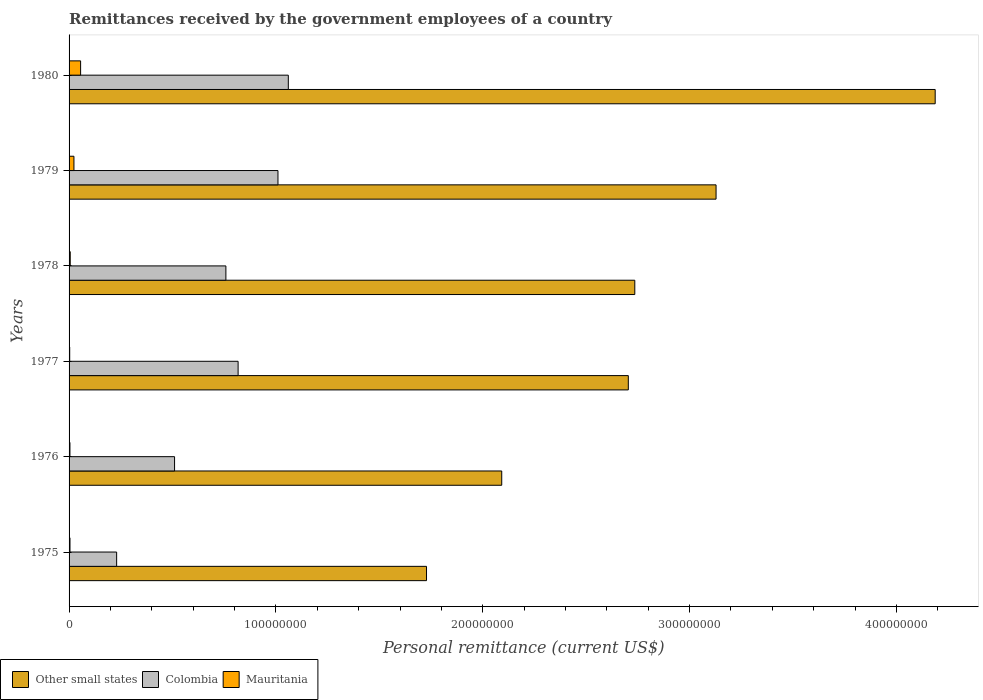Are the number of bars per tick equal to the number of legend labels?
Offer a terse response. Yes. How many bars are there on the 4th tick from the top?
Provide a short and direct response. 3. How many bars are there on the 5th tick from the bottom?
Keep it short and to the point. 3. What is the label of the 6th group of bars from the top?
Your answer should be compact. 1975. What is the remittances received by the government employees in Other small states in 1977?
Make the answer very short. 2.70e+08. Across all years, what is the maximum remittances received by the government employees in Mauritania?
Provide a succinct answer. 5.58e+06. Across all years, what is the minimum remittances received by the government employees in Other small states?
Keep it short and to the point. 1.73e+08. In which year was the remittances received by the government employees in Colombia maximum?
Offer a terse response. 1980. In which year was the remittances received by the government employees in Colombia minimum?
Keep it short and to the point. 1975. What is the total remittances received by the government employees in Other small states in the graph?
Your response must be concise. 1.66e+09. What is the difference between the remittances received by the government employees in Mauritania in 1976 and that in 1979?
Offer a very short reply. -1.93e+06. What is the difference between the remittances received by the government employees in Other small states in 1980 and the remittances received by the government employees in Mauritania in 1975?
Offer a terse response. 4.18e+08. What is the average remittances received by the government employees in Mauritania per year?
Your answer should be compact. 1.61e+06. In the year 1976, what is the difference between the remittances received by the government employees in Colombia and remittances received by the government employees in Other small states?
Provide a succinct answer. -1.58e+08. What is the ratio of the remittances received by the government employees in Other small states in 1977 to that in 1979?
Your answer should be compact. 0.86. Is the remittances received by the government employees in Colombia in 1975 less than that in 1980?
Provide a short and direct response. Yes. What is the difference between the highest and the second highest remittances received by the government employees in Other small states?
Your answer should be very brief. 1.06e+08. What is the difference between the highest and the lowest remittances received by the government employees in Mauritania?
Provide a short and direct response. 5.27e+06. In how many years, is the remittances received by the government employees in Other small states greater than the average remittances received by the government employees in Other small states taken over all years?
Give a very brief answer. 2. Is the sum of the remittances received by the government employees in Other small states in 1976 and 1980 greater than the maximum remittances received by the government employees in Colombia across all years?
Offer a very short reply. Yes. What does the 2nd bar from the bottom in 1976 represents?
Your answer should be compact. Colombia. How many bars are there?
Provide a succinct answer. 18. Are all the bars in the graph horizontal?
Offer a terse response. Yes. How many years are there in the graph?
Your answer should be very brief. 6. Does the graph contain any zero values?
Ensure brevity in your answer.  No. Does the graph contain grids?
Provide a short and direct response. No. How are the legend labels stacked?
Offer a terse response. Horizontal. What is the title of the graph?
Provide a succinct answer. Remittances received by the government employees of a country. Does "Macedonia" appear as one of the legend labels in the graph?
Your answer should be compact. No. What is the label or title of the X-axis?
Keep it short and to the point. Personal remittance (current US$). What is the Personal remittance (current US$) in Other small states in 1975?
Offer a very short reply. 1.73e+08. What is the Personal remittance (current US$) of Colombia in 1975?
Offer a terse response. 2.30e+07. What is the Personal remittance (current US$) of Mauritania in 1975?
Offer a terse response. 4.41e+05. What is the Personal remittance (current US$) in Other small states in 1976?
Ensure brevity in your answer.  2.09e+08. What is the Personal remittance (current US$) in Colombia in 1976?
Provide a short and direct response. 5.10e+07. What is the Personal remittance (current US$) of Mauritania in 1976?
Offer a very short reply. 4.22e+05. What is the Personal remittance (current US$) of Other small states in 1977?
Make the answer very short. 2.70e+08. What is the Personal remittance (current US$) of Colombia in 1977?
Offer a terse response. 8.17e+07. What is the Personal remittance (current US$) of Mauritania in 1977?
Offer a very short reply. 3.07e+05. What is the Personal remittance (current US$) of Other small states in 1978?
Your answer should be very brief. 2.74e+08. What is the Personal remittance (current US$) in Colombia in 1978?
Offer a terse response. 7.58e+07. What is the Personal remittance (current US$) of Mauritania in 1978?
Your response must be concise. 5.63e+05. What is the Personal remittance (current US$) in Other small states in 1979?
Your response must be concise. 3.13e+08. What is the Personal remittance (current US$) of Colombia in 1979?
Make the answer very short. 1.01e+08. What is the Personal remittance (current US$) in Mauritania in 1979?
Ensure brevity in your answer.  2.35e+06. What is the Personal remittance (current US$) of Other small states in 1980?
Your answer should be compact. 4.19e+08. What is the Personal remittance (current US$) in Colombia in 1980?
Keep it short and to the point. 1.06e+08. What is the Personal remittance (current US$) of Mauritania in 1980?
Your answer should be very brief. 5.58e+06. Across all years, what is the maximum Personal remittance (current US$) in Other small states?
Your response must be concise. 4.19e+08. Across all years, what is the maximum Personal remittance (current US$) in Colombia?
Give a very brief answer. 1.06e+08. Across all years, what is the maximum Personal remittance (current US$) in Mauritania?
Offer a terse response. 5.58e+06. Across all years, what is the minimum Personal remittance (current US$) in Other small states?
Your response must be concise. 1.73e+08. Across all years, what is the minimum Personal remittance (current US$) in Colombia?
Provide a succinct answer. 2.30e+07. Across all years, what is the minimum Personal remittance (current US$) in Mauritania?
Your answer should be compact. 3.07e+05. What is the total Personal remittance (current US$) of Other small states in the graph?
Your answer should be very brief. 1.66e+09. What is the total Personal remittance (current US$) in Colombia in the graph?
Give a very brief answer. 4.39e+08. What is the total Personal remittance (current US$) in Mauritania in the graph?
Your response must be concise. 9.66e+06. What is the difference between the Personal remittance (current US$) in Other small states in 1975 and that in 1976?
Ensure brevity in your answer.  -3.64e+07. What is the difference between the Personal remittance (current US$) in Colombia in 1975 and that in 1976?
Your answer should be compact. -2.80e+07. What is the difference between the Personal remittance (current US$) in Mauritania in 1975 and that in 1976?
Keep it short and to the point. 1.88e+04. What is the difference between the Personal remittance (current US$) of Other small states in 1975 and that in 1977?
Offer a very short reply. -9.76e+07. What is the difference between the Personal remittance (current US$) in Colombia in 1975 and that in 1977?
Your response must be concise. -5.87e+07. What is the difference between the Personal remittance (current US$) of Mauritania in 1975 and that in 1977?
Keep it short and to the point. 1.34e+05. What is the difference between the Personal remittance (current US$) of Other small states in 1975 and that in 1978?
Give a very brief answer. -1.01e+08. What is the difference between the Personal remittance (current US$) in Colombia in 1975 and that in 1978?
Ensure brevity in your answer.  -5.28e+07. What is the difference between the Personal remittance (current US$) in Mauritania in 1975 and that in 1978?
Your answer should be very brief. -1.22e+05. What is the difference between the Personal remittance (current US$) of Other small states in 1975 and that in 1979?
Give a very brief answer. -1.40e+08. What is the difference between the Personal remittance (current US$) of Colombia in 1975 and that in 1979?
Keep it short and to the point. -7.80e+07. What is the difference between the Personal remittance (current US$) of Mauritania in 1975 and that in 1979?
Provide a succinct answer. -1.91e+06. What is the difference between the Personal remittance (current US$) in Other small states in 1975 and that in 1980?
Your answer should be very brief. -2.46e+08. What is the difference between the Personal remittance (current US$) in Colombia in 1975 and that in 1980?
Your response must be concise. -8.30e+07. What is the difference between the Personal remittance (current US$) of Mauritania in 1975 and that in 1980?
Keep it short and to the point. -5.13e+06. What is the difference between the Personal remittance (current US$) in Other small states in 1976 and that in 1977?
Offer a terse response. -6.12e+07. What is the difference between the Personal remittance (current US$) of Colombia in 1976 and that in 1977?
Offer a terse response. -3.07e+07. What is the difference between the Personal remittance (current US$) in Mauritania in 1976 and that in 1977?
Give a very brief answer. 1.15e+05. What is the difference between the Personal remittance (current US$) in Other small states in 1976 and that in 1978?
Ensure brevity in your answer.  -6.43e+07. What is the difference between the Personal remittance (current US$) of Colombia in 1976 and that in 1978?
Your answer should be compact. -2.48e+07. What is the difference between the Personal remittance (current US$) of Mauritania in 1976 and that in 1978?
Give a very brief answer. -1.41e+05. What is the difference between the Personal remittance (current US$) in Other small states in 1976 and that in 1979?
Ensure brevity in your answer.  -1.04e+08. What is the difference between the Personal remittance (current US$) in Colombia in 1976 and that in 1979?
Provide a short and direct response. -5.00e+07. What is the difference between the Personal remittance (current US$) in Mauritania in 1976 and that in 1979?
Your answer should be very brief. -1.93e+06. What is the difference between the Personal remittance (current US$) in Other small states in 1976 and that in 1980?
Your answer should be compact. -2.10e+08. What is the difference between the Personal remittance (current US$) in Colombia in 1976 and that in 1980?
Ensure brevity in your answer.  -5.50e+07. What is the difference between the Personal remittance (current US$) in Mauritania in 1976 and that in 1980?
Provide a succinct answer. -5.15e+06. What is the difference between the Personal remittance (current US$) of Other small states in 1977 and that in 1978?
Offer a very short reply. -3.13e+06. What is the difference between the Personal remittance (current US$) in Colombia in 1977 and that in 1978?
Ensure brevity in your answer.  5.91e+06. What is the difference between the Personal remittance (current US$) in Mauritania in 1977 and that in 1978?
Your answer should be compact. -2.56e+05. What is the difference between the Personal remittance (current US$) of Other small states in 1977 and that in 1979?
Your response must be concise. -4.24e+07. What is the difference between the Personal remittance (current US$) of Colombia in 1977 and that in 1979?
Ensure brevity in your answer.  -1.93e+07. What is the difference between the Personal remittance (current US$) in Mauritania in 1977 and that in 1979?
Ensure brevity in your answer.  -2.05e+06. What is the difference between the Personal remittance (current US$) of Other small states in 1977 and that in 1980?
Your answer should be compact. -1.48e+08. What is the difference between the Personal remittance (current US$) of Colombia in 1977 and that in 1980?
Keep it short and to the point. -2.43e+07. What is the difference between the Personal remittance (current US$) in Mauritania in 1977 and that in 1980?
Offer a terse response. -5.27e+06. What is the difference between the Personal remittance (current US$) of Other small states in 1978 and that in 1979?
Provide a succinct answer. -3.93e+07. What is the difference between the Personal remittance (current US$) of Colombia in 1978 and that in 1979?
Ensure brevity in your answer.  -2.52e+07. What is the difference between the Personal remittance (current US$) in Mauritania in 1978 and that in 1979?
Make the answer very short. -1.79e+06. What is the difference between the Personal remittance (current US$) in Other small states in 1978 and that in 1980?
Offer a terse response. -1.45e+08. What is the difference between the Personal remittance (current US$) in Colombia in 1978 and that in 1980?
Your answer should be very brief. -3.02e+07. What is the difference between the Personal remittance (current US$) of Mauritania in 1978 and that in 1980?
Provide a short and direct response. -5.01e+06. What is the difference between the Personal remittance (current US$) in Other small states in 1979 and that in 1980?
Offer a terse response. -1.06e+08. What is the difference between the Personal remittance (current US$) in Colombia in 1979 and that in 1980?
Offer a very short reply. -5.00e+06. What is the difference between the Personal remittance (current US$) in Mauritania in 1979 and that in 1980?
Provide a succinct answer. -3.22e+06. What is the difference between the Personal remittance (current US$) in Other small states in 1975 and the Personal remittance (current US$) in Colombia in 1976?
Provide a succinct answer. 1.22e+08. What is the difference between the Personal remittance (current US$) of Other small states in 1975 and the Personal remittance (current US$) of Mauritania in 1976?
Make the answer very short. 1.72e+08. What is the difference between the Personal remittance (current US$) of Colombia in 1975 and the Personal remittance (current US$) of Mauritania in 1976?
Provide a succinct answer. 2.26e+07. What is the difference between the Personal remittance (current US$) in Other small states in 1975 and the Personal remittance (current US$) in Colombia in 1977?
Provide a short and direct response. 9.11e+07. What is the difference between the Personal remittance (current US$) of Other small states in 1975 and the Personal remittance (current US$) of Mauritania in 1977?
Ensure brevity in your answer.  1.73e+08. What is the difference between the Personal remittance (current US$) in Colombia in 1975 and the Personal remittance (current US$) in Mauritania in 1977?
Ensure brevity in your answer.  2.27e+07. What is the difference between the Personal remittance (current US$) in Other small states in 1975 and the Personal remittance (current US$) in Colombia in 1978?
Your answer should be very brief. 9.70e+07. What is the difference between the Personal remittance (current US$) in Other small states in 1975 and the Personal remittance (current US$) in Mauritania in 1978?
Your response must be concise. 1.72e+08. What is the difference between the Personal remittance (current US$) of Colombia in 1975 and the Personal remittance (current US$) of Mauritania in 1978?
Keep it short and to the point. 2.24e+07. What is the difference between the Personal remittance (current US$) in Other small states in 1975 and the Personal remittance (current US$) in Colombia in 1979?
Make the answer very short. 7.18e+07. What is the difference between the Personal remittance (current US$) in Other small states in 1975 and the Personal remittance (current US$) in Mauritania in 1979?
Give a very brief answer. 1.70e+08. What is the difference between the Personal remittance (current US$) in Colombia in 1975 and the Personal remittance (current US$) in Mauritania in 1979?
Your answer should be very brief. 2.06e+07. What is the difference between the Personal remittance (current US$) in Other small states in 1975 and the Personal remittance (current US$) in Colombia in 1980?
Make the answer very short. 6.68e+07. What is the difference between the Personal remittance (current US$) of Other small states in 1975 and the Personal remittance (current US$) of Mauritania in 1980?
Your answer should be compact. 1.67e+08. What is the difference between the Personal remittance (current US$) in Colombia in 1975 and the Personal remittance (current US$) in Mauritania in 1980?
Keep it short and to the point. 1.74e+07. What is the difference between the Personal remittance (current US$) in Other small states in 1976 and the Personal remittance (current US$) in Colombia in 1977?
Ensure brevity in your answer.  1.27e+08. What is the difference between the Personal remittance (current US$) in Other small states in 1976 and the Personal remittance (current US$) in Mauritania in 1977?
Offer a terse response. 2.09e+08. What is the difference between the Personal remittance (current US$) of Colombia in 1976 and the Personal remittance (current US$) of Mauritania in 1977?
Your answer should be very brief. 5.07e+07. What is the difference between the Personal remittance (current US$) in Other small states in 1976 and the Personal remittance (current US$) in Colombia in 1978?
Your answer should be compact. 1.33e+08. What is the difference between the Personal remittance (current US$) in Other small states in 1976 and the Personal remittance (current US$) in Mauritania in 1978?
Make the answer very short. 2.09e+08. What is the difference between the Personal remittance (current US$) in Colombia in 1976 and the Personal remittance (current US$) in Mauritania in 1978?
Your answer should be compact. 5.04e+07. What is the difference between the Personal remittance (current US$) in Other small states in 1976 and the Personal remittance (current US$) in Colombia in 1979?
Keep it short and to the point. 1.08e+08. What is the difference between the Personal remittance (current US$) in Other small states in 1976 and the Personal remittance (current US$) in Mauritania in 1979?
Your answer should be very brief. 2.07e+08. What is the difference between the Personal remittance (current US$) in Colombia in 1976 and the Personal remittance (current US$) in Mauritania in 1979?
Make the answer very short. 4.86e+07. What is the difference between the Personal remittance (current US$) of Other small states in 1976 and the Personal remittance (current US$) of Colombia in 1980?
Offer a very short reply. 1.03e+08. What is the difference between the Personal remittance (current US$) in Other small states in 1976 and the Personal remittance (current US$) in Mauritania in 1980?
Ensure brevity in your answer.  2.04e+08. What is the difference between the Personal remittance (current US$) in Colombia in 1976 and the Personal remittance (current US$) in Mauritania in 1980?
Your response must be concise. 4.54e+07. What is the difference between the Personal remittance (current US$) of Other small states in 1977 and the Personal remittance (current US$) of Colombia in 1978?
Your answer should be very brief. 1.95e+08. What is the difference between the Personal remittance (current US$) of Other small states in 1977 and the Personal remittance (current US$) of Mauritania in 1978?
Your answer should be very brief. 2.70e+08. What is the difference between the Personal remittance (current US$) in Colombia in 1977 and the Personal remittance (current US$) in Mauritania in 1978?
Your answer should be very brief. 8.12e+07. What is the difference between the Personal remittance (current US$) in Other small states in 1977 and the Personal remittance (current US$) in Colombia in 1979?
Your response must be concise. 1.69e+08. What is the difference between the Personal remittance (current US$) in Other small states in 1977 and the Personal remittance (current US$) in Mauritania in 1979?
Your answer should be very brief. 2.68e+08. What is the difference between the Personal remittance (current US$) in Colombia in 1977 and the Personal remittance (current US$) in Mauritania in 1979?
Give a very brief answer. 7.94e+07. What is the difference between the Personal remittance (current US$) of Other small states in 1977 and the Personal remittance (current US$) of Colombia in 1980?
Ensure brevity in your answer.  1.64e+08. What is the difference between the Personal remittance (current US$) of Other small states in 1977 and the Personal remittance (current US$) of Mauritania in 1980?
Provide a succinct answer. 2.65e+08. What is the difference between the Personal remittance (current US$) of Colombia in 1977 and the Personal remittance (current US$) of Mauritania in 1980?
Keep it short and to the point. 7.62e+07. What is the difference between the Personal remittance (current US$) in Other small states in 1978 and the Personal remittance (current US$) in Colombia in 1979?
Keep it short and to the point. 1.73e+08. What is the difference between the Personal remittance (current US$) of Other small states in 1978 and the Personal remittance (current US$) of Mauritania in 1979?
Provide a succinct answer. 2.71e+08. What is the difference between the Personal remittance (current US$) in Colombia in 1978 and the Personal remittance (current US$) in Mauritania in 1979?
Offer a terse response. 7.35e+07. What is the difference between the Personal remittance (current US$) in Other small states in 1978 and the Personal remittance (current US$) in Colombia in 1980?
Provide a short and direct response. 1.68e+08. What is the difference between the Personal remittance (current US$) in Other small states in 1978 and the Personal remittance (current US$) in Mauritania in 1980?
Make the answer very short. 2.68e+08. What is the difference between the Personal remittance (current US$) of Colombia in 1978 and the Personal remittance (current US$) of Mauritania in 1980?
Provide a short and direct response. 7.02e+07. What is the difference between the Personal remittance (current US$) of Other small states in 1979 and the Personal remittance (current US$) of Colombia in 1980?
Offer a terse response. 2.07e+08. What is the difference between the Personal remittance (current US$) in Other small states in 1979 and the Personal remittance (current US$) in Mauritania in 1980?
Ensure brevity in your answer.  3.07e+08. What is the difference between the Personal remittance (current US$) in Colombia in 1979 and the Personal remittance (current US$) in Mauritania in 1980?
Make the answer very short. 9.54e+07. What is the average Personal remittance (current US$) in Other small states per year?
Make the answer very short. 2.76e+08. What is the average Personal remittance (current US$) of Colombia per year?
Ensure brevity in your answer.  7.31e+07. What is the average Personal remittance (current US$) in Mauritania per year?
Your response must be concise. 1.61e+06. In the year 1975, what is the difference between the Personal remittance (current US$) in Other small states and Personal remittance (current US$) in Colombia?
Your answer should be very brief. 1.50e+08. In the year 1975, what is the difference between the Personal remittance (current US$) of Other small states and Personal remittance (current US$) of Mauritania?
Offer a terse response. 1.72e+08. In the year 1975, what is the difference between the Personal remittance (current US$) of Colombia and Personal remittance (current US$) of Mauritania?
Make the answer very short. 2.26e+07. In the year 1976, what is the difference between the Personal remittance (current US$) in Other small states and Personal remittance (current US$) in Colombia?
Offer a very short reply. 1.58e+08. In the year 1976, what is the difference between the Personal remittance (current US$) of Other small states and Personal remittance (current US$) of Mauritania?
Your answer should be compact. 2.09e+08. In the year 1976, what is the difference between the Personal remittance (current US$) of Colombia and Personal remittance (current US$) of Mauritania?
Keep it short and to the point. 5.06e+07. In the year 1977, what is the difference between the Personal remittance (current US$) in Other small states and Personal remittance (current US$) in Colombia?
Your response must be concise. 1.89e+08. In the year 1977, what is the difference between the Personal remittance (current US$) of Other small states and Personal remittance (current US$) of Mauritania?
Offer a terse response. 2.70e+08. In the year 1977, what is the difference between the Personal remittance (current US$) in Colombia and Personal remittance (current US$) in Mauritania?
Ensure brevity in your answer.  8.14e+07. In the year 1978, what is the difference between the Personal remittance (current US$) in Other small states and Personal remittance (current US$) in Colombia?
Offer a very short reply. 1.98e+08. In the year 1978, what is the difference between the Personal remittance (current US$) of Other small states and Personal remittance (current US$) of Mauritania?
Keep it short and to the point. 2.73e+08. In the year 1978, what is the difference between the Personal remittance (current US$) in Colombia and Personal remittance (current US$) in Mauritania?
Provide a short and direct response. 7.53e+07. In the year 1979, what is the difference between the Personal remittance (current US$) of Other small states and Personal remittance (current US$) of Colombia?
Provide a succinct answer. 2.12e+08. In the year 1979, what is the difference between the Personal remittance (current US$) of Other small states and Personal remittance (current US$) of Mauritania?
Provide a succinct answer. 3.10e+08. In the year 1979, what is the difference between the Personal remittance (current US$) of Colombia and Personal remittance (current US$) of Mauritania?
Give a very brief answer. 9.86e+07. In the year 1980, what is the difference between the Personal remittance (current US$) of Other small states and Personal remittance (current US$) of Colombia?
Your answer should be very brief. 3.13e+08. In the year 1980, what is the difference between the Personal remittance (current US$) in Other small states and Personal remittance (current US$) in Mauritania?
Offer a very short reply. 4.13e+08. In the year 1980, what is the difference between the Personal remittance (current US$) in Colombia and Personal remittance (current US$) in Mauritania?
Your answer should be very brief. 1.00e+08. What is the ratio of the Personal remittance (current US$) of Other small states in 1975 to that in 1976?
Ensure brevity in your answer.  0.83. What is the ratio of the Personal remittance (current US$) of Colombia in 1975 to that in 1976?
Provide a short and direct response. 0.45. What is the ratio of the Personal remittance (current US$) in Mauritania in 1975 to that in 1976?
Your answer should be compact. 1.04. What is the ratio of the Personal remittance (current US$) of Other small states in 1975 to that in 1977?
Offer a very short reply. 0.64. What is the ratio of the Personal remittance (current US$) of Colombia in 1975 to that in 1977?
Give a very brief answer. 0.28. What is the ratio of the Personal remittance (current US$) of Mauritania in 1975 to that in 1977?
Your answer should be very brief. 1.44. What is the ratio of the Personal remittance (current US$) in Other small states in 1975 to that in 1978?
Your answer should be compact. 0.63. What is the ratio of the Personal remittance (current US$) in Colombia in 1975 to that in 1978?
Keep it short and to the point. 0.3. What is the ratio of the Personal remittance (current US$) of Mauritania in 1975 to that in 1978?
Your answer should be compact. 0.78. What is the ratio of the Personal remittance (current US$) of Other small states in 1975 to that in 1979?
Provide a succinct answer. 0.55. What is the ratio of the Personal remittance (current US$) of Colombia in 1975 to that in 1979?
Provide a short and direct response. 0.23. What is the ratio of the Personal remittance (current US$) of Mauritania in 1975 to that in 1979?
Your answer should be very brief. 0.19. What is the ratio of the Personal remittance (current US$) in Other small states in 1975 to that in 1980?
Your answer should be compact. 0.41. What is the ratio of the Personal remittance (current US$) in Colombia in 1975 to that in 1980?
Offer a terse response. 0.22. What is the ratio of the Personal remittance (current US$) of Mauritania in 1975 to that in 1980?
Give a very brief answer. 0.08. What is the ratio of the Personal remittance (current US$) in Other small states in 1976 to that in 1977?
Ensure brevity in your answer.  0.77. What is the ratio of the Personal remittance (current US$) in Colombia in 1976 to that in 1977?
Your response must be concise. 0.62. What is the ratio of the Personal remittance (current US$) of Mauritania in 1976 to that in 1977?
Your answer should be compact. 1.37. What is the ratio of the Personal remittance (current US$) in Other small states in 1976 to that in 1978?
Your answer should be very brief. 0.76. What is the ratio of the Personal remittance (current US$) of Colombia in 1976 to that in 1978?
Provide a succinct answer. 0.67. What is the ratio of the Personal remittance (current US$) in Mauritania in 1976 to that in 1978?
Make the answer very short. 0.75. What is the ratio of the Personal remittance (current US$) of Other small states in 1976 to that in 1979?
Offer a terse response. 0.67. What is the ratio of the Personal remittance (current US$) of Colombia in 1976 to that in 1979?
Your answer should be compact. 0.51. What is the ratio of the Personal remittance (current US$) in Mauritania in 1976 to that in 1979?
Make the answer very short. 0.18. What is the ratio of the Personal remittance (current US$) of Other small states in 1976 to that in 1980?
Offer a terse response. 0.5. What is the ratio of the Personal remittance (current US$) of Colombia in 1976 to that in 1980?
Offer a very short reply. 0.48. What is the ratio of the Personal remittance (current US$) in Mauritania in 1976 to that in 1980?
Your answer should be very brief. 0.08. What is the ratio of the Personal remittance (current US$) in Other small states in 1977 to that in 1978?
Your answer should be compact. 0.99. What is the ratio of the Personal remittance (current US$) in Colombia in 1977 to that in 1978?
Give a very brief answer. 1.08. What is the ratio of the Personal remittance (current US$) in Mauritania in 1977 to that in 1978?
Offer a very short reply. 0.55. What is the ratio of the Personal remittance (current US$) in Other small states in 1977 to that in 1979?
Make the answer very short. 0.86. What is the ratio of the Personal remittance (current US$) in Colombia in 1977 to that in 1979?
Your answer should be compact. 0.81. What is the ratio of the Personal remittance (current US$) in Mauritania in 1977 to that in 1979?
Provide a succinct answer. 0.13. What is the ratio of the Personal remittance (current US$) in Other small states in 1977 to that in 1980?
Provide a succinct answer. 0.65. What is the ratio of the Personal remittance (current US$) of Colombia in 1977 to that in 1980?
Offer a terse response. 0.77. What is the ratio of the Personal remittance (current US$) in Mauritania in 1977 to that in 1980?
Provide a succinct answer. 0.06. What is the ratio of the Personal remittance (current US$) of Other small states in 1978 to that in 1979?
Offer a very short reply. 0.87. What is the ratio of the Personal remittance (current US$) in Colombia in 1978 to that in 1979?
Your answer should be compact. 0.75. What is the ratio of the Personal remittance (current US$) of Mauritania in 1978 to that in 1979?
Offer a terse response. 0.24. What is the ratio of the Personal remittance (current US$) in Other small states in 1978 to that in 1980?
Your response must be concise. 0.65. What is the ratio of the Personal remittance (current US$) of Colombia in 1978 to that in 1980?
Keep it short and to the point. 0.72. What is the ratio of the Personal remittance (current US$) in Mauritania in 1978 to that in 1980?
Offer a terse response. 0.1. What is the ratio of the Personal remittance (current US$) of Other small states in 1979 to that in 1980?
Provide a short and direct response. 0.75. What is the ratio of the Personal remittance (current US$) in Colombia in 1979 to that in 1980?
Your answer should be very brief. 0.95. What is the ratio of the Personal remittance (current US$) in Mauritania in 1979 to that in 1980?
Give a very brief answer. 0.42. What is the difference between the highest and the second highest Personal remittance (current US$) in Other small states?
Ensure brevity in your answer.  1.06e+08. What is the difference between the highest and the second highest Personal remittance (current US$) of Mauritania?
Ensure brevity in your answer.  3.22e+06. What is the difference between the highest and the lowest Personal remittance (current US$) in Other small states?
Your answer should be very brief. 2.46e+08. What is the difference between the highest and the lowest Personal remittance (current US$) of Colombia?
Give a very brief answer. 8.30e+07. What is the difference between the highest and the lowest Personal remittance (current US$) of Mauritania?
Make the answer very short. 5.27e+06. 